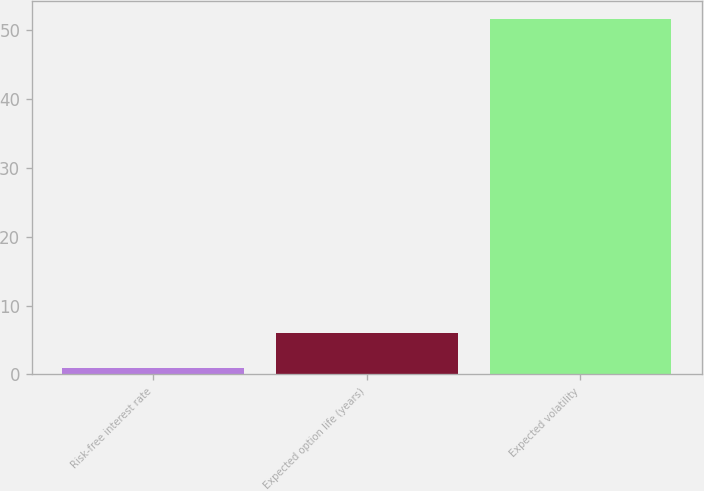Convert chart to OTSL. <chart><loc_0><loc_0><loc_500><loc_500><bar_chart><fcel>Risk-free interest rate<fcel>Expected option life (years)<fcel>Expected volatility<nl><fcel>0.94<fcel>6.02<fcel>51.7<nl></chart> 